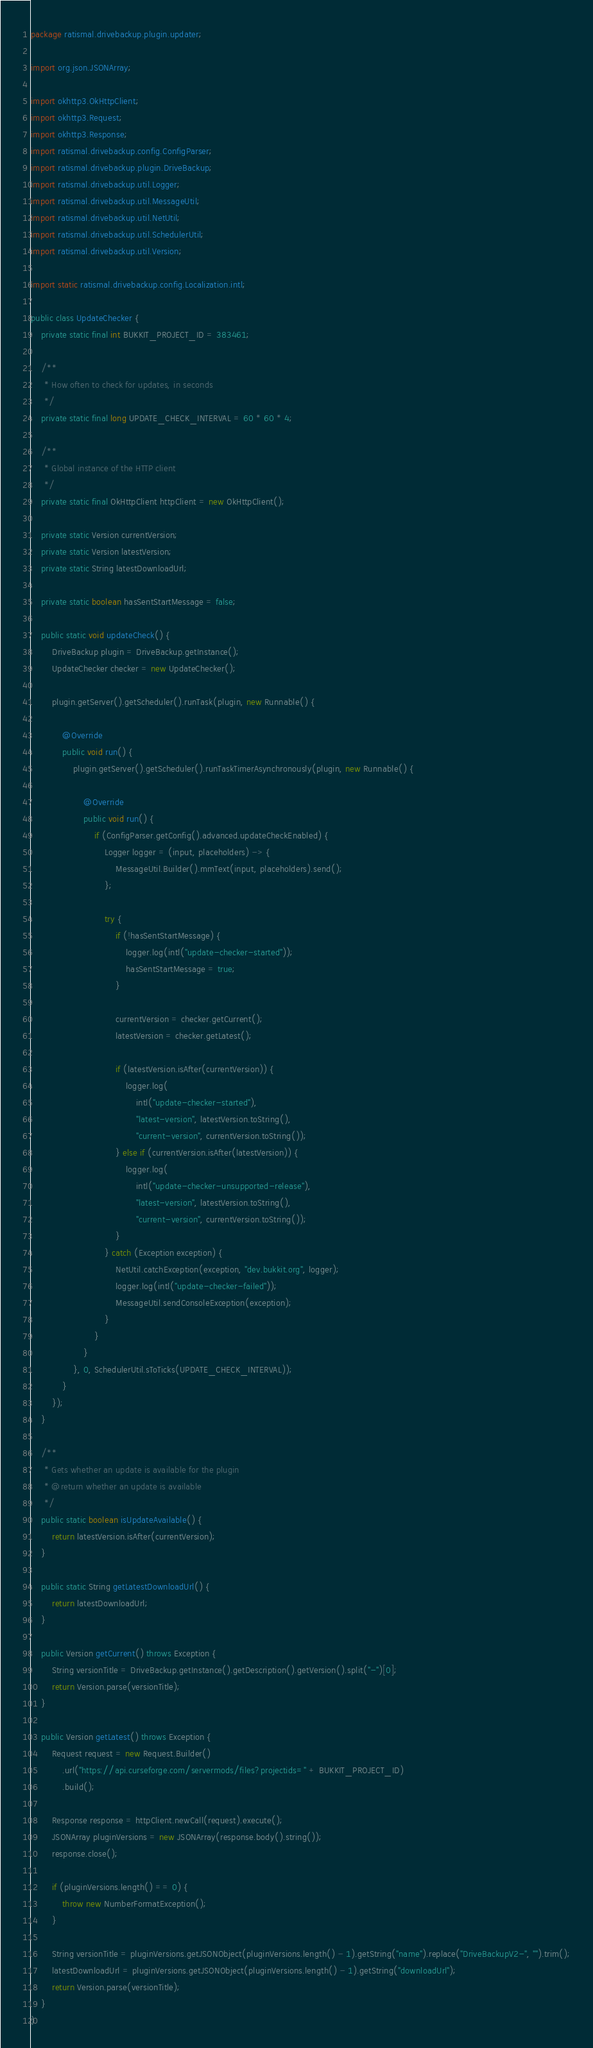<code> <loc_0><loc_0><loc_500><loc_500><_Java_>package ratismal.drivebackup.plugin.updater;

import org.json.JSONArray;

import okhttp3.OkHttpClient;
import okhttp3.Request;
import okhttp3.Response;
import ratismal.drivebackup.config.ConfigParser;
import ratismal.drivebackup.plugin.DriveBackup;
import ratismal.drivebackup.util.Logger;
import ratismal.drivebackup.util.MessageUtil;
import ratismal.drivebackup.util.NetUtil;
import ratismal.drivebackup.util.SchedulerUtil;
import ratismal.drivebackup.util.Version;

import static ratismal.drivebackup.config.Localization.intl;

public class UpdateChecker {
    private static final int BUKKIT_PROJECT_ID = 383461;

    /**
     * How often to check for updates, in seconds
     */
    private static final long UPDATE_CHECK_INTERVAL = 60 * 60 * 4;

    /**
     * Global instance of the HTTP client
     */
    private static final OkHttpClient httpClient = new OkHttpClient();

    private static Version currentVersion;
    private static Version latestVersion;
    private static String latestDownloadUrl;

    private static boolean hasSentStartMessage = false;

    public static void updateCheck() {
        DriveBackup plugin = DriveBackup.getInstance();
        UpdateChecker checker = new UpdateChecker();

        plugin.getServer().getScheduler().runTask(plugin, new Runnable() {

            @Override
            public void run() {
                plugin.getServer().getScheduler().runTaskTimerAsynchronously(plugin, new Runnable() {

                    @Override
                    public void run() {
                        if (ConfigParser.getConfig().advanced.updateCheckEnabled) {
                            Logger logger = (input, placeholders) -> {
                                MessageUtil.Builder().mmText(input, placeholders).send();
                            };

                            try {
                                if (!hasSentStartMessage) {
                                    logger.log(intl("update-checker-started"));
                                    hasSentStartMessage = true;
                                }

                                currentVersion = checker.getCurrent();
                                latestVersion = checker.getLatest();

                                if (latestVersion.isAfter(currentVersion)) {
                                    logger.log(
                                        intl("update-checker-started"),
                                        "latest-version", latestVersion.toString(),
                                        "current-version", currentVersion.toString());
                                } else if (currentVersion.isAfter(latestVersion)) {
                                    logger.log(
                                        intl("update-checker-unsupported-release"),
                                        "latest-version", latestVersion.toString(),
                                        "current-version", currentVersion.toString());
                                }
                            } catch (Exception exception) {
                                NetUtil.catchException(exception, "dev.bukkit.org", logger);
                                logger.log(intl("update-checker-failed"));
                                MessageUtil.sendConsoleException(exception);
                            }
                        }
                    }
                }, 0, SchedulerUtil.sToTicks(UPDATE_CHECK_INTERVAL));
            }
        });
    }

    /**
     * Gets whether an update is available for the plugin
     * @return whether an update is available
     */
    public static boolean isUpdateAvailable() {
        return latestVersion.isAfter(currentVersion);
    }

    public static String getLatestDownloadUrl() {
        return latestDownloadUrl;
    }

    public Version getCurrent() throws Exception {
        String versionTitle = DriveBackup.getInstance().getDescription().getVersion().split("-")[0];
        return Version.parse(versionTitle);
    }

    public Version getLatest() throws Exception {
        Request request = new Request.Builder()
            .url("https://api.curseforge.com/servermods/files?projectids=" + BUKKIT_PROJECT_ID)
            .build();

        Response response = httpClient.newCall(request).execute();
        JSONArray pluginVersions = new JSONArray(response.body().string());
        response.close();

        if (pluginVersions.length() == 0) {
            throw new NumberFormatException();
        }

        String versionTitle = pluginVersions.getJSONObject(pluginVersions.length() - 1).getString("name").replace("DriveBackupV2-", "").trim();
        latestDownloadUrl = pluginVersions.getJSONObject(pluginVersions.length() - 1).getString("downloadUrl");
        return Version.parse(versionTitle);
    }
}
</code> 